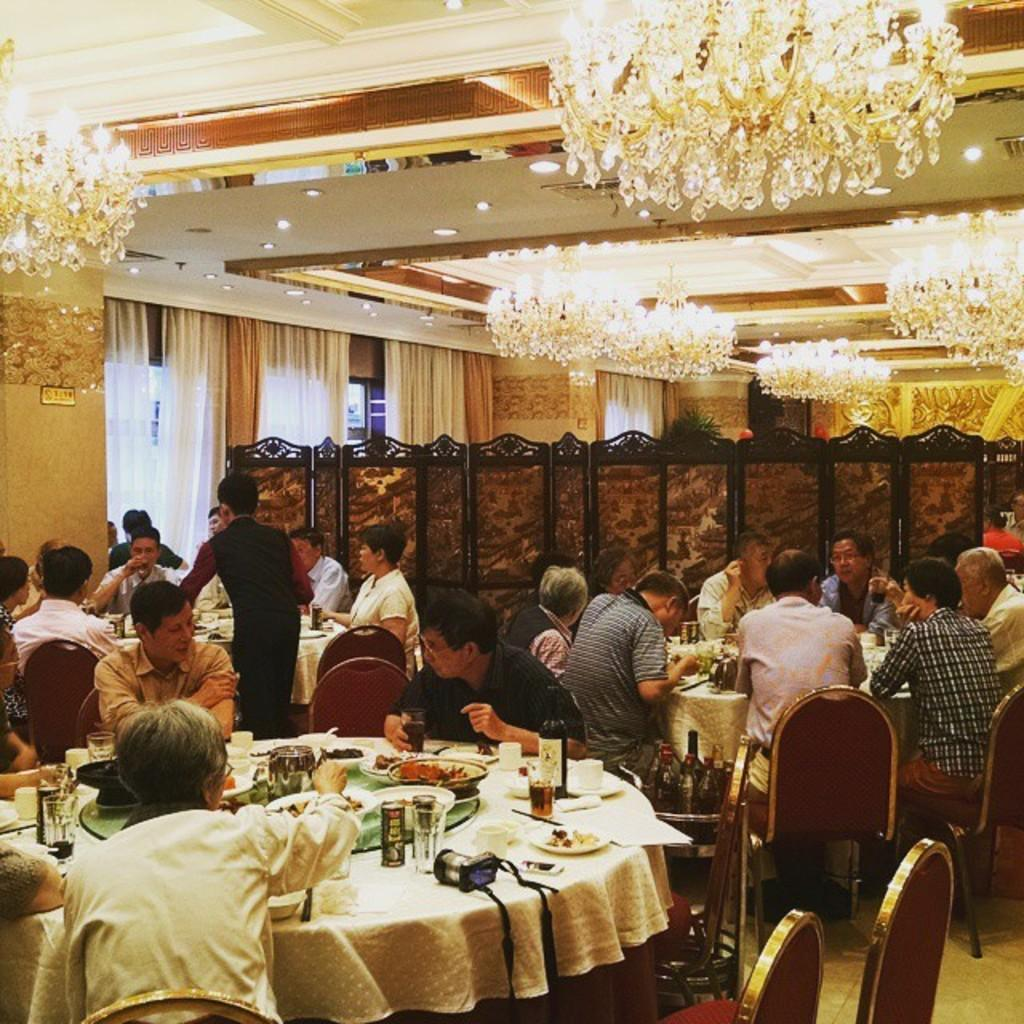How many people are in the image? There is a group of people in the image. What are the people doing in the image? The people are sitting on chairs. What is on the table in the image? There is a plate and a bottle on the table. What can be seen in the background of the image? There is a curtain and lights in the background. What type of sticks are being used for the vacation in the image? There is no mention of sticks or a vacation in the image. 